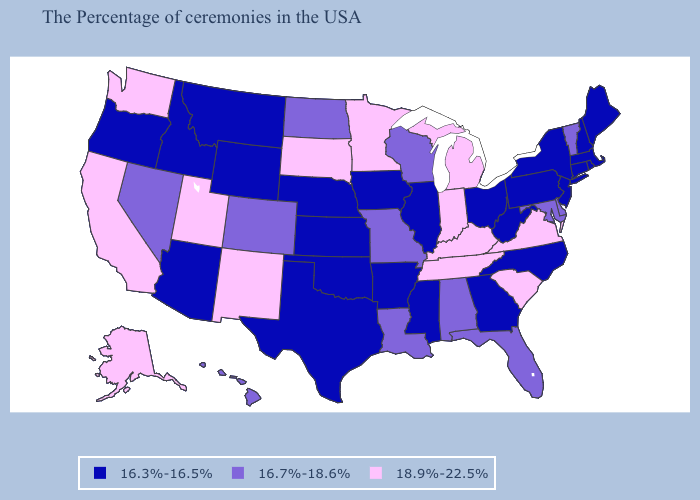Among the states that border Georgia , which have the highest value?
Write a very short answer. South Carolina, Tennessee. What is the value of Illinois?
Quick response, please. 16.3%-16.5%. Among the states that border North Carolina , which have the lowest value?
Answer briefly. Georgia. What is the highest value in the USA?
Concise answer only. 18.9%-22.5%. Which states have the lowest value in the Northeast?
Quick response, please. Maine, Massachusetts, Rhode Island, New Hampshire, Connecticut, New York, New Jersey, Pennsylvania. Does North Dakota have the lowest value in the USA?
Quick response, please. No. Among the states that border Indiana , which have the highest value?
Give a very brief answer. Michigan, Kentucky. Does Kentucky have the highest value in the USA?
Answer briefly. Yes. What is the value of Montana?
Keep it brief. 16.3%-16.5%. Is the legend a continuous bar?
Answer briefly. No. Does Kentucky have the same value as California?
Keep it brief. Yes. Name the states that have a value in the range 16.3%-16.5%?
Keep it brief. Maine, Massachusetts, Rhode Island, New Hampshire, Connecticut, New York, New Jersey, Pennsylvania, North Carolina, West Virginia, Ohio, Georgia, Illinois, Mississippi, Arkansas, Iowa, Kansas, Nebraska, Oklahoma, Texas, Wyoming, Montana, Arizona, Idaho, Oregon. Does Missouri have the highest value in the MidWest?
Short answer required. No. Name the states that have a value in the range 18.9%-22.5%?
Give a very brief answer. Virginia, South Carolina, Michigan, Kentucky, Indiana, Tennessee, Minnesota, South Dakota, New Mexico, Utah, California, Washington, Alaska. What is the value of Montana?
Quick response, please. 16.3%-16.5%. 